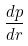Convert formula to latex. <formula><loc_0><loc_0><loc_500><loc_500>\frac { d p } { d r }</formula> 